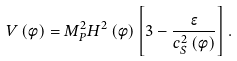<formula> <loc_0><loc_0><loc_500><loc_500>V \left ( \phi \right ) = M _ { P } ^ { 2 } H ^ { 2 } \left ( \phi \right ) \left [ 3 - \frac { \epsilon } { c _ { S } ^ { 2 } \left ( \phi \right ) } \right ] .</formula> 